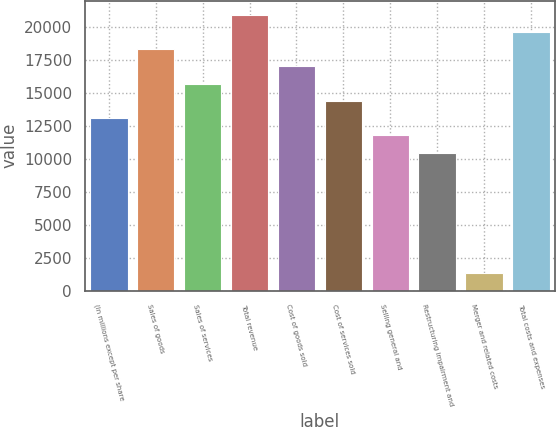<chart> <loc_0><loc_0><loc_500><loc_500><bar_chart><fcel>(In millions except per share<fcel>Sales of goods<fcel>Sales of services<fcel>Total revenue<fcel>Cost of goods sold<fcel>Cost of services sold<fcel>Selling general and<fcel>Restructuring impairment and<fcel>Merger and related costs<fcel>Total costs and expenses<nl><fcel>13082<fcel>18313.6<fcel>15697.8<fcel>20929.4<fcel>17005.7<fcel>14389.9<fcel>11774.1<fcel>10466.2<fcel>1310.9<fcel>19621.5<nl></chart> 